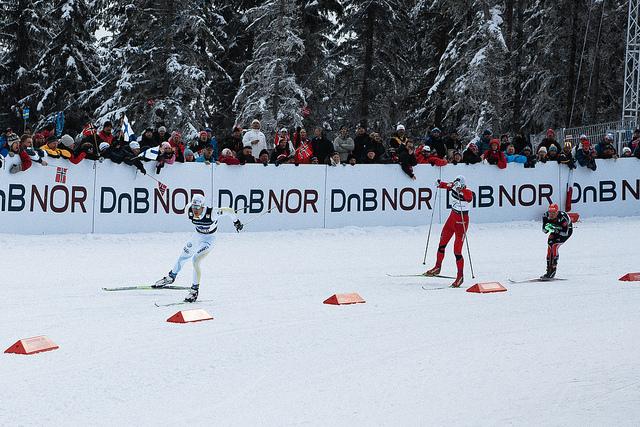What color is the line in the snow?
Short answer required. Red. What is all over the ice?
Quick response, please. Skiers. What are the orange things?
Keep it brief. Cones. What major holiday was this event near?
Keep it brief. Christmas. Are they snowboarding?
Keep it brief. No. What is written on the wall?
Be succinct. Dnbnor. Are they riding bikes on ice?
Concise answer only. No. What kind of event is this?
Keep it brief. Skiing. 